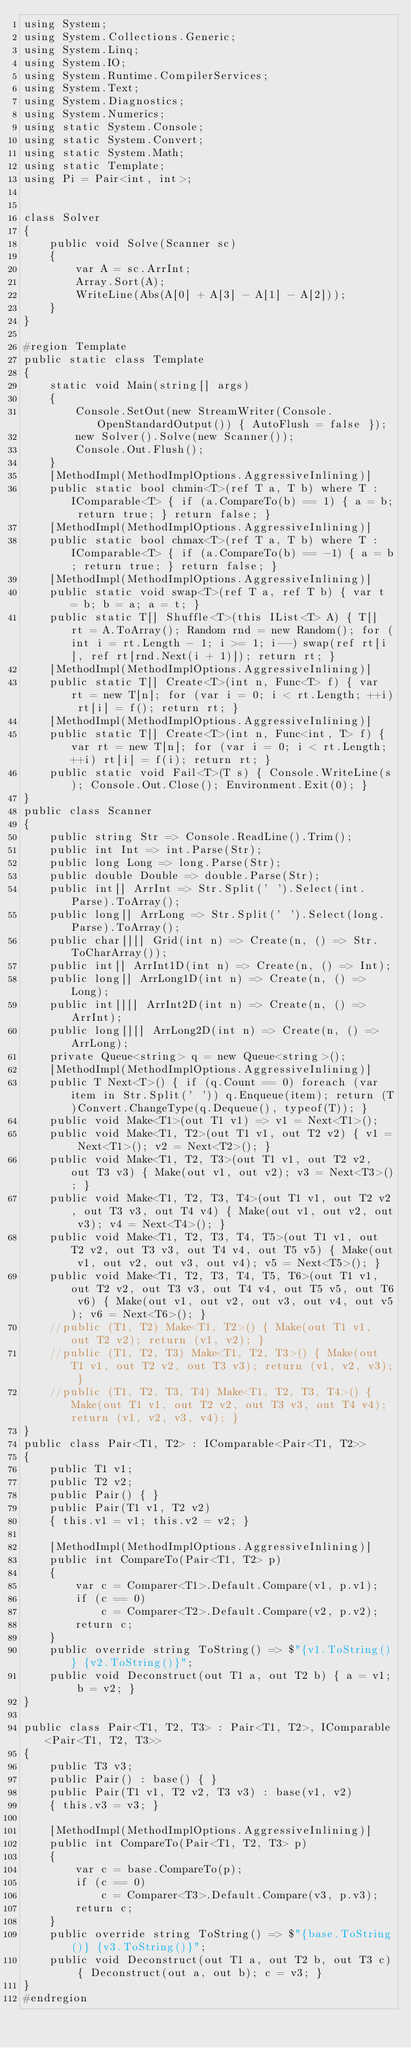<code> <loc_0><loc_0><loc_500><loc_500><_C#_>using System;
using System.Collections.Generic;
using System.Linq;
using System.IO;
using System.Runtime.CompilerServices;
using System.Text;
using System.Diagnostics;
using System.Numerics;
using static System.Console;
using static System.Convert;
using static System.Math;
using static Template;
using Pi = Pair<int, int>;


class Solver
{
    public void Solve(Scanner sc)
    {
        var A = sc.ArrInt;
        Array.Sort(A);
        WriteLine(Abs(A[0] + A[3] - A[1] - A[2]));
    }
}

#region Template
public static class Template
{
    static void Main(string[] args)
    {
        Console.SetOut(new StreamWriter(Console.OpenStandardOutput()) { AutoFlush = false });
        new Solver().Solve(new Scanner());
        Console.Out.Flush();
    }
    [MethodImpl(MethodImplOptions.AggressiveInlining)]
    public static bool chmin<T>(ref T a, T b) where T : IComparable<T> { if (a.CompareTo(b) == 1) { a = b; return true; } return false; }
    [MethodImpl(MethodImplOptions.AggressiveInlining)]
    public static bool chmax<T>(ref T a, T b) where T : IComparable<T> { if (a.CompareTo(b) == -1) { a = b; return true; } return false; }
    [MethodImpl(MethodImplOptions.AggressiveInlining)]
    public static void swap<T>(ref T a, ref T b) { var t = b; b = a; a = t; }
    public static T[] Shuffle<T>(this IList<T> A) { T[] rt = A.ToArray(); Random rnd = new Random(); for (int i = rt.Length - 1; i >= 1; i--) swap(ref rt[i], ref rt[rnd.Next(i + 1)]); return rt; }
    [MethodImpl(MethodImplOptions.AggressiveInlining)]
    public static T[] Create<T>(int n, Func<T> f) { var rt = new T[n]; for (var i = 0; i < rt.Length; ++i) rt[i] = f(); return rt; }
    [MethodImpl(MethodImplOptions.AggressiveInlining)]
    public static T[] Create<T>(int n, Func<int, T> f) { var rt = new T[n]; for (var i = 0; i < rt.Length; ++i) rt[i] = f(i); return rt; }
    public static void Fail<T>(T s) { Console.WriteLine(s); Console.Out.Close(); Environment.Exit(0); }
}
public class Scanner
{
    public string Str => Console.ReadLine().Trim();
    public int Int => int.Parse(Str);
    public long Long => long.Parse(Str);
    public double Double => double.Parse(Str);
    public int[] ArrInt => Str.Split(' ').Select(int.Parse).ToArray();
    public long[] ArrLong => Str.Split(' ').Select(long.Parse).ToArray();
    public char[][] Grid(int n) => Create(n, () => Str.ToCharArray());
    public int[] ArrInt1D(int n) => Create(n, () => Int);
    public long[] ArrLong1D(int n) => Create(n, () => Long);
    public int[][] ArrInt2D(int n) => Create(n, () => ArrInt);
    public long[][] ArrLong2D(int n) => Create(n, () => ArrLong);
    private Queue<string> q = new Queue<string>();
    [MethodImpl(MethodImplOptions.AggressiveInlining)]
    public T Next<T>() { if (q.Count == 0) foreach (var item in Str.Split(' ')) q.Enqueue(item); return (T)Convert.ChangeType(q.Dequeue(), typeof(T)); }
    public void Make<T1>(out T1 v1) => v1 = Next<T1>();
    public void Make<T1, T2>(out T1 v1, out T2 v2) { v1 = Next<T1>(); v2 = Next<T2>(); }
    public void Make<T1, T2, T3>(out T1 v1, out T2 v2, out T3 v3) { Make(out v1, out v2); v3 = Next<T3>(); }
    public void Make<T1, T2, T3, T4>(out T1 v1, out T2 v2, out T3 v3, out T4 v4) { Make(out v1, out v2, out v3); v4 = Next<T4>(); }
    public void Make<T1, T2, T3, T4, T5>(out T1 v1, out T2 v2, out T3 v3, out T4 v4, out T5 v5) { Make(out v1, out v2, out v3, out v4); v5 = Next<T5>(); }
    public void Make<T1, T2, T3, T4, T5, T6>(out T1 v1, out T2 v2, out T3 v3, out T4 v4, out T5 v5, out T6 v6) { Make(out v1, out v2, out v3, out v4, out v5); v6 = Next<T6>(); }
    //public (T1, T2) Make<T1, T2>() { Make(out T1 v1, out T2 v2); return (v1, v2); }
    //public (T1, T2, T3) Make<T1, T2, T3>() { Make(out T1 v1, out T2 v2, out T3 v3); return (v1, v2, v3); }
    //public (T1, T2, T3, T4) Make<T1, T2, T3, T4>() { Make(out T1 v1, out T2 v2, out T3 v3, out T4 v4); return (v1, v2, v3, v4); }
}
public class Pair<T1, T2> : IComparable<Pair<T1, T2>>
{
    public T1 v1;
    public T2 v2;
    public Pair() { }
    public Pair(T1 v1, T2 v2)
    { this.v1 = v1; this.v2 = v2; }

    [MethodImpl(MethodImplOptions.AggressiveInlining)]
    public int CompareTo(Pair<T1, T2> p)
    {
        var c = Comparer<T1>.Default.Compare(v1, p.v1);
        if (c == 0)
            c = Comparer<T2>.Default.Compare(v2, p.v2);
        return c;
    }
    public override string ToString() => $"{v1.ToString()} {v2.ToString()}";
    public void Deconstruct(out T1 a, out T2 b) { a = v1; b = v2; }
}

public class Pair<T1, T2, T3> : Pair<T1, T2>, IComparable<Pair<T1, T2, T3>>
{
    public T3 v3;
    public Pair() : base() { }
    public Pair(T1 v1, T2 v2, T3 v3) : base(v1, v2)
    { this.v3 = v3; }

    [MethodImpl(MethodImplOptions.AggressiveInlining)]
    public int CompareTo(Pair<T1, T2, T3> p)
    {
        var c = base.CompareTo(p);
        if (c == 0)
            c = Comparer<T3>.Default.Compare(v3, p.v3);
        return c;
    }
    public override string ToString() => $"{base.ToString()} {v3.ToString()}";
    public void Deconstruct(out T1 a, out T2 b, out T3 c) { Deconstruct(out a, out b); c = v3; }
}
#endregion
</code> 